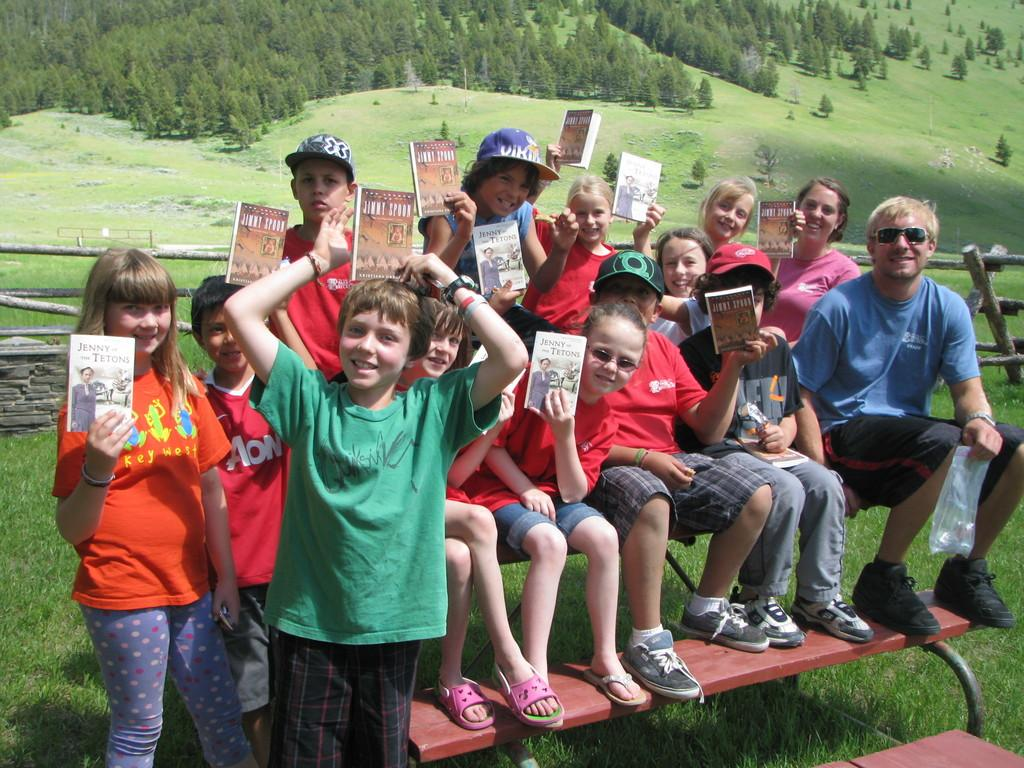What are the kids holding in the image? The kids are holding books in the image. What positions are the kids in? Some kids are sitting in the image. What is the man holding? The man is holding a cover in the image. What architectural feature can be seen in the image? There are steps visible in the image. What type of vegetation is present in the image? Grass is present in the image. What type of barrier is visible in the image? There is a wooden fence in the image. What can be seen in the background of the image? Trees and grass are visible in the background of the image. What hobbies do the kids have, as indicated by their crying in the image? There is no indication that the kids are crying in the image, and therefore no information about their hobbies can be inferred from their emotional state. 